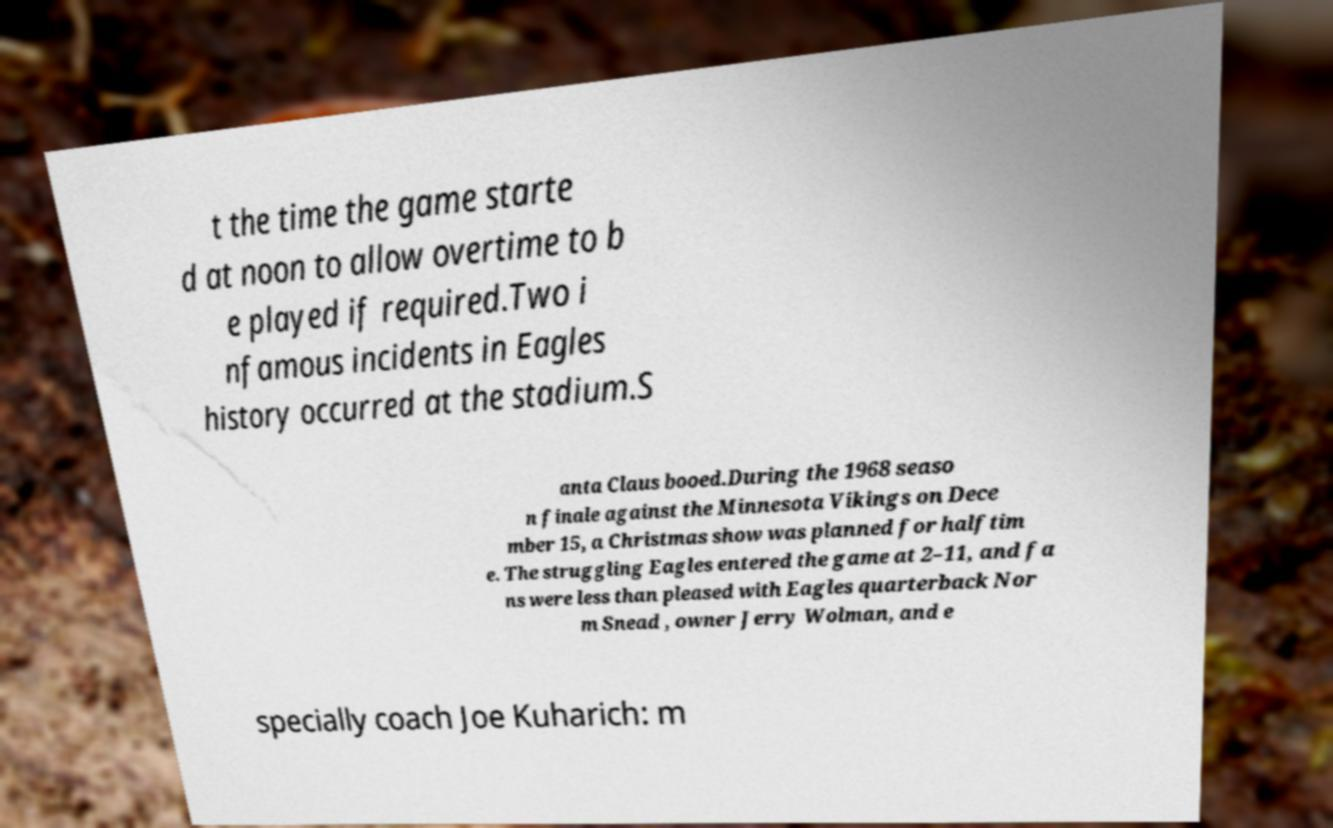Could you extract and type out the text from this image? t the time the game starte d at noon to allow overtime to b e played if required.Two i nfamous incidents in Eagles history occurred at the stadium.S anta Claus booed.During the 1968 seaso n finale against the Minnesota Vikings on Dece mber 15, a Christmas show was planned for halftim e. The struggling Eagles entered the game at 2–11, and fa ns were less than pleased with Eagles quarterback Nor m Snead , owner Jerry Wolman, and e specially coach Joe Kuharich: m 